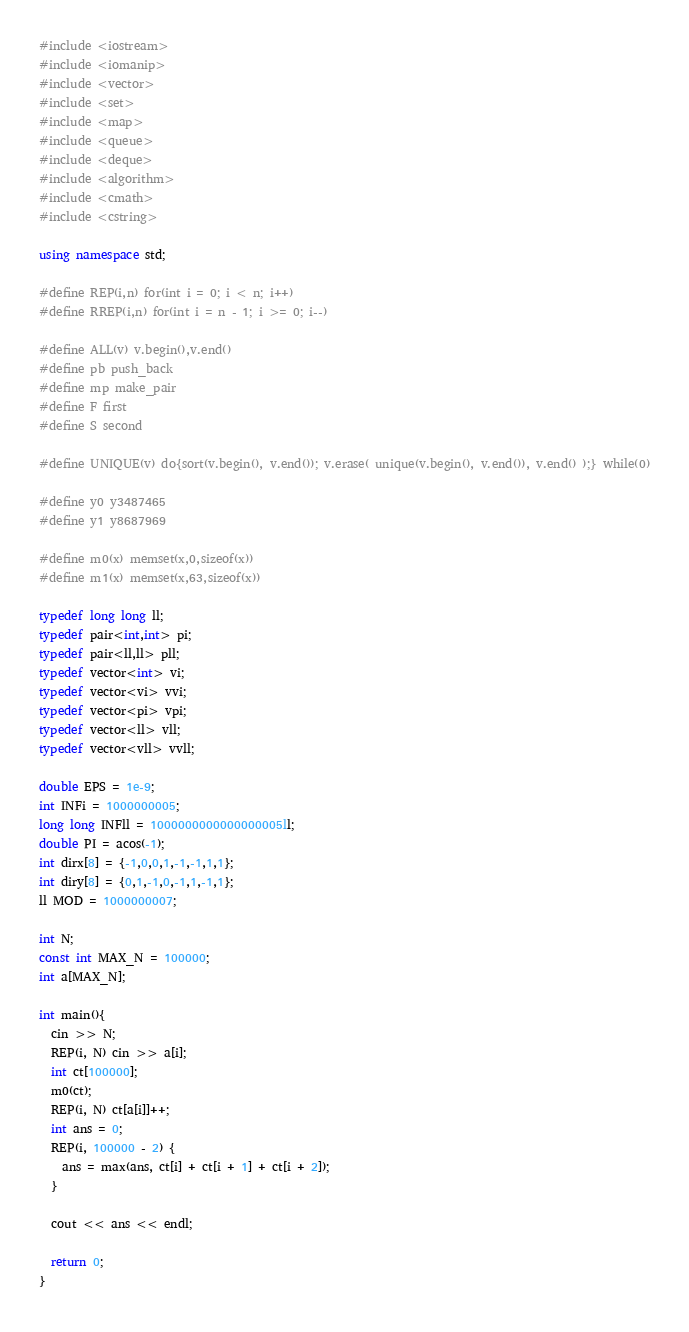Convert code to text. <code><loc_0><loc_0><loc_500><loc_500><_C++_>#include <iostream>
#include <iomanip>
#include <vector>
#include <set>
#include <map>
#include <queue>
#include <deque>
#include <algorithm>
#include <cmath>
#include <cstring>

using namespace std;

#define REP(i,n) for(int i = 0; i < n; i++)
#define RREP(i,n) for(int i = n - 1; i >= 0; i--)

#define ALL(v) v.begin(),v.end()
#define pb push_back
#define mp make_pair
#define F first
#define S second

#define UNIQUE(v) do{sort(v.begin(), v.end()); v.erase( unique(v.begin(), v.end()), v.end() );} while(0)

#define y0 y3487465
#define y1 y8687969

#define m0(x) memset(x,0,sizeof(x))
#define m1(x) memset(x,63,sizeof(x))

typedef long long ll;
typedef pair<int,int> pi;
typedef pair<ll,ll> pll;
typedef vector<int> vi;
typedef vector<vi> vvi;
typedef vector<pi> vpi;
typedef vector<ll> vll;
typedef vector<vll> vvll;

double EPS = 1e-9;
int INFi = 1000000005;
long long INFll = 1000000000000000005ll;
double PI = acos(-1);
int dirx[8] = {-1,0,0,1,-1,-1,1,1};
int diry[8] = {0,1,-1,0,-1,1,-1,1};
ll MOD = 1000000007;

int N;
const int MAX_N = 100000;
int a[MAX_N];

int main(){
  cin >> N;
  REP(i, N) cin >> a[i];
  int ct[100000];
  m0(ct);
  REP(i, N) ct[a[i]]++;
  int ans = 0;
  REP(i, 100000 - 2) {
    ans = max(ans, ct[i] + ct[i + 1] + ct[i + 2]);
  }

  cout << ans << endl;

  return 0;
}
</code> 